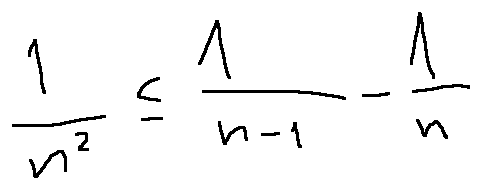<formula> <loc_0><loc_0><loc_500><loc_500>\frac { 1 } { n ^ { 2 } } \leq \frac { 1 } { n - 1 } - \frac { 1 } { n }</formula> 